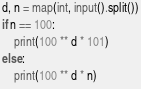<code> <loc_0><loc_0><loc_500><loc_500><_Python_>d, n = map(int, input().split())
if n == 100:
    print(100 ** d * 101)
else:
    print(100 ** d * n)</code> 